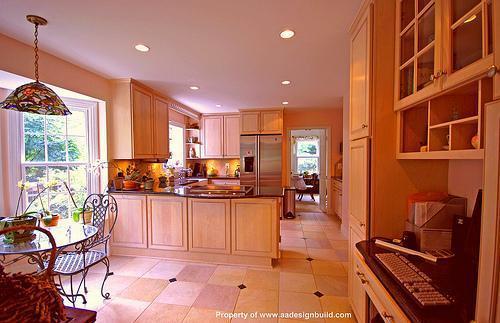How many chairs can you see?
Give a very brief answer. 2. How many recessed lights can you see?
Give a very brief answer. 6. 